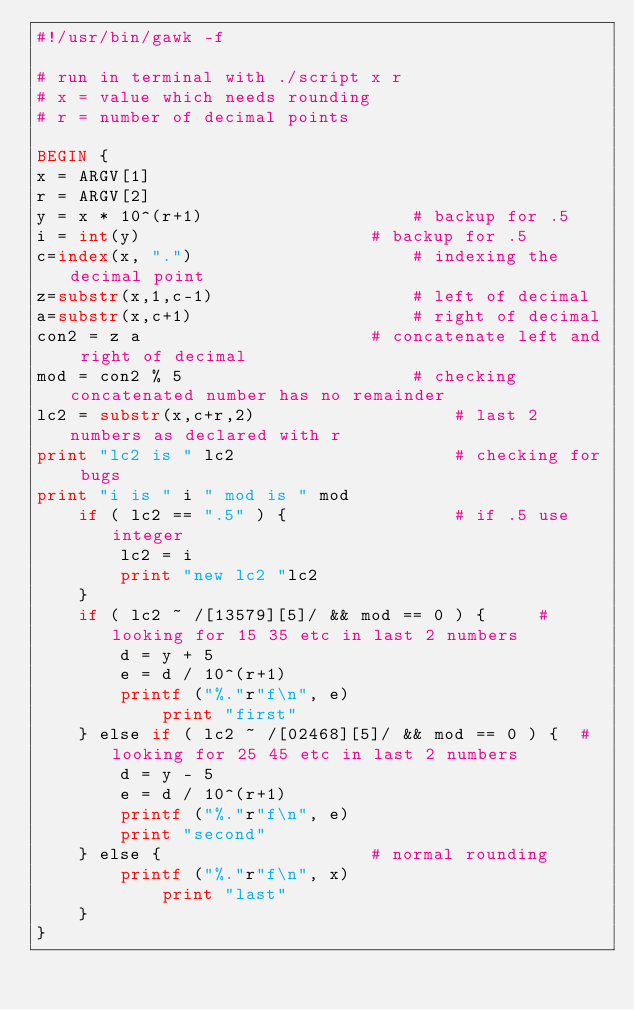Convert code to text. <code><loc_0><loc_0><loc_500><loc_500><_Awk_>#!/usr/bin/gawk -f

# run in terminal with ./script x r 
# x = value which needs rounding
# r = number of decimal points

BEGIN {
x = ARGV[1]
r = ARGV[2]
y = x * 10^(r+1)					# backup for .5
i = int(y)						# backup for .5
c=index(x, ".")						# indexing the decimal point
z=substr(x,1,c-1)					# left of decimal
a=substr(x,c+1)						# right of decimal
con2 = z a						# concatenate left and right of decimal
mod = con2 % 5						# checking concatenated number has no remainder
lc2 = substr(x,c+r,2)					# last 2 numbers as declared with r
print "lc2 is " lc2 					# checking for bugs
print "i is " i " mod is " mod
	if ( lc2 == ".5" ) {				# if .5 use integer
		lc2 = i
		print "new lc2 "lc2
	}
	if ( lc2 ~ /[13579][5]/ && mod == 0 ) {		# looking for 15 35 etc in last 2 numbers
		d = y + 5
		e = d / 10^(r+1)
		printf ("%."r"f\n", e)
	        print "first"	
	} else if ( lc2 ~ /[02468][5]/ && mod == 0 ) {	# looking for 25 45 etc in last 2 numbers
		d = y - 5
		e = d / 10^(r+1)
		printf ("%."r"f\n", e) 
		print "second"
	} else {					# normal rounding
		printf ("%."r"f\n", x)
	        print "last"	
	}
}
</code> 